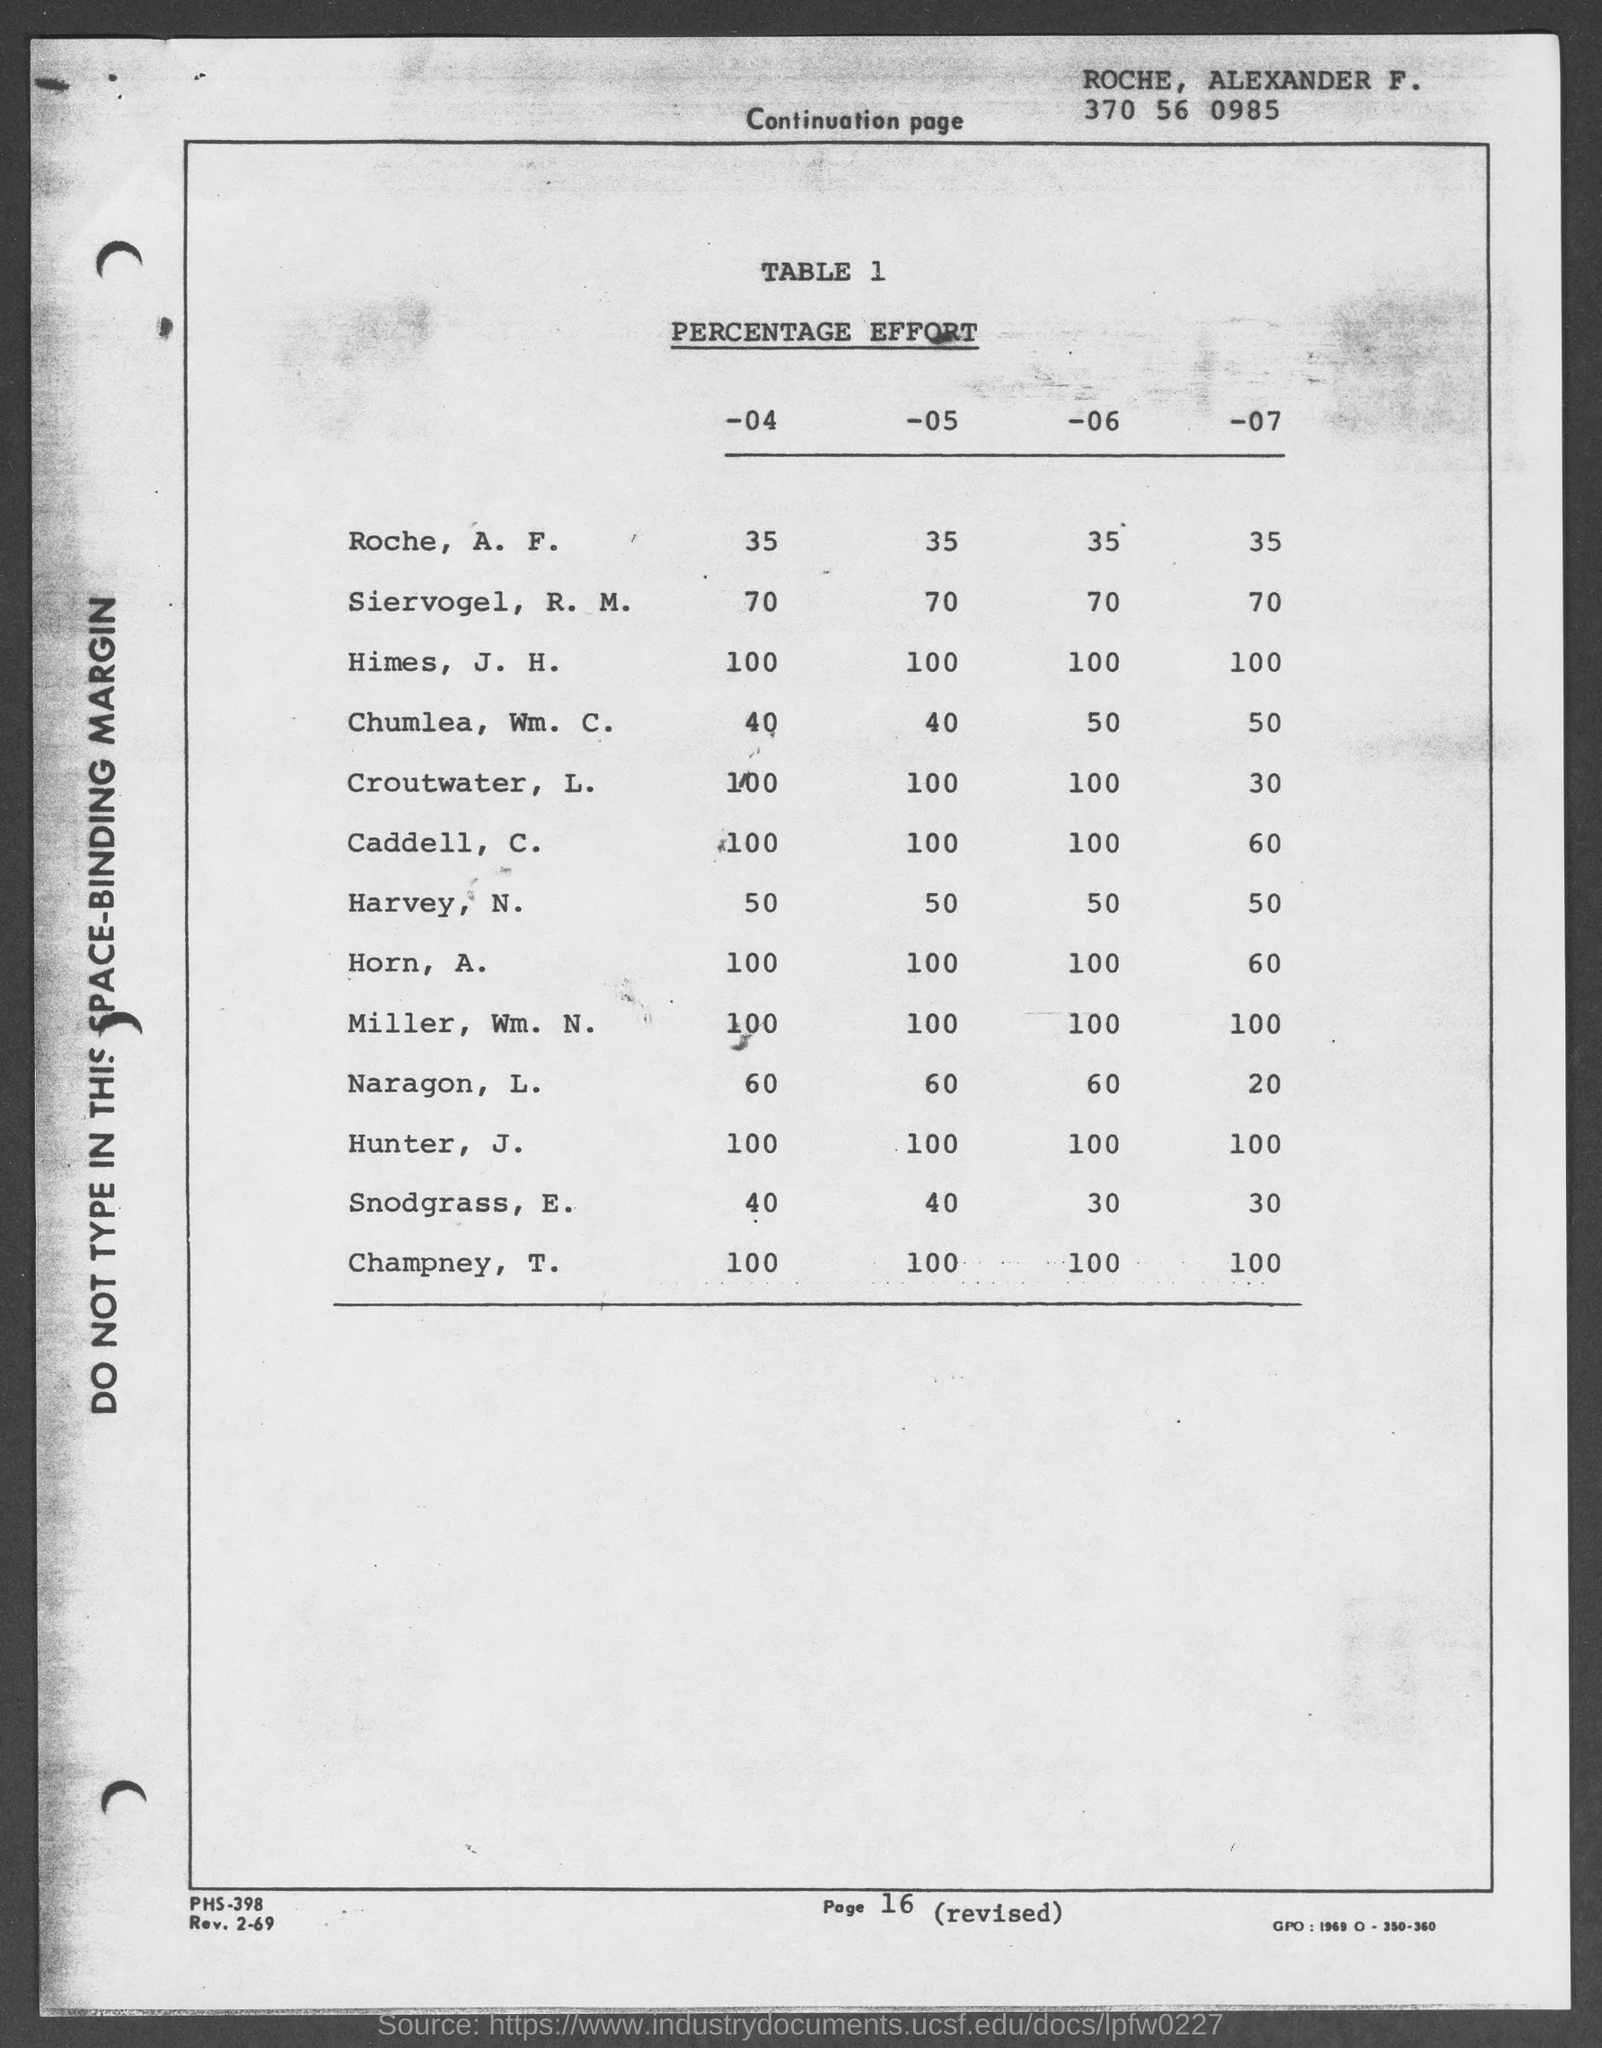Which name written in the Top of the Document ?
Your response must be concise. ROCHE, ALEXANDER F. 